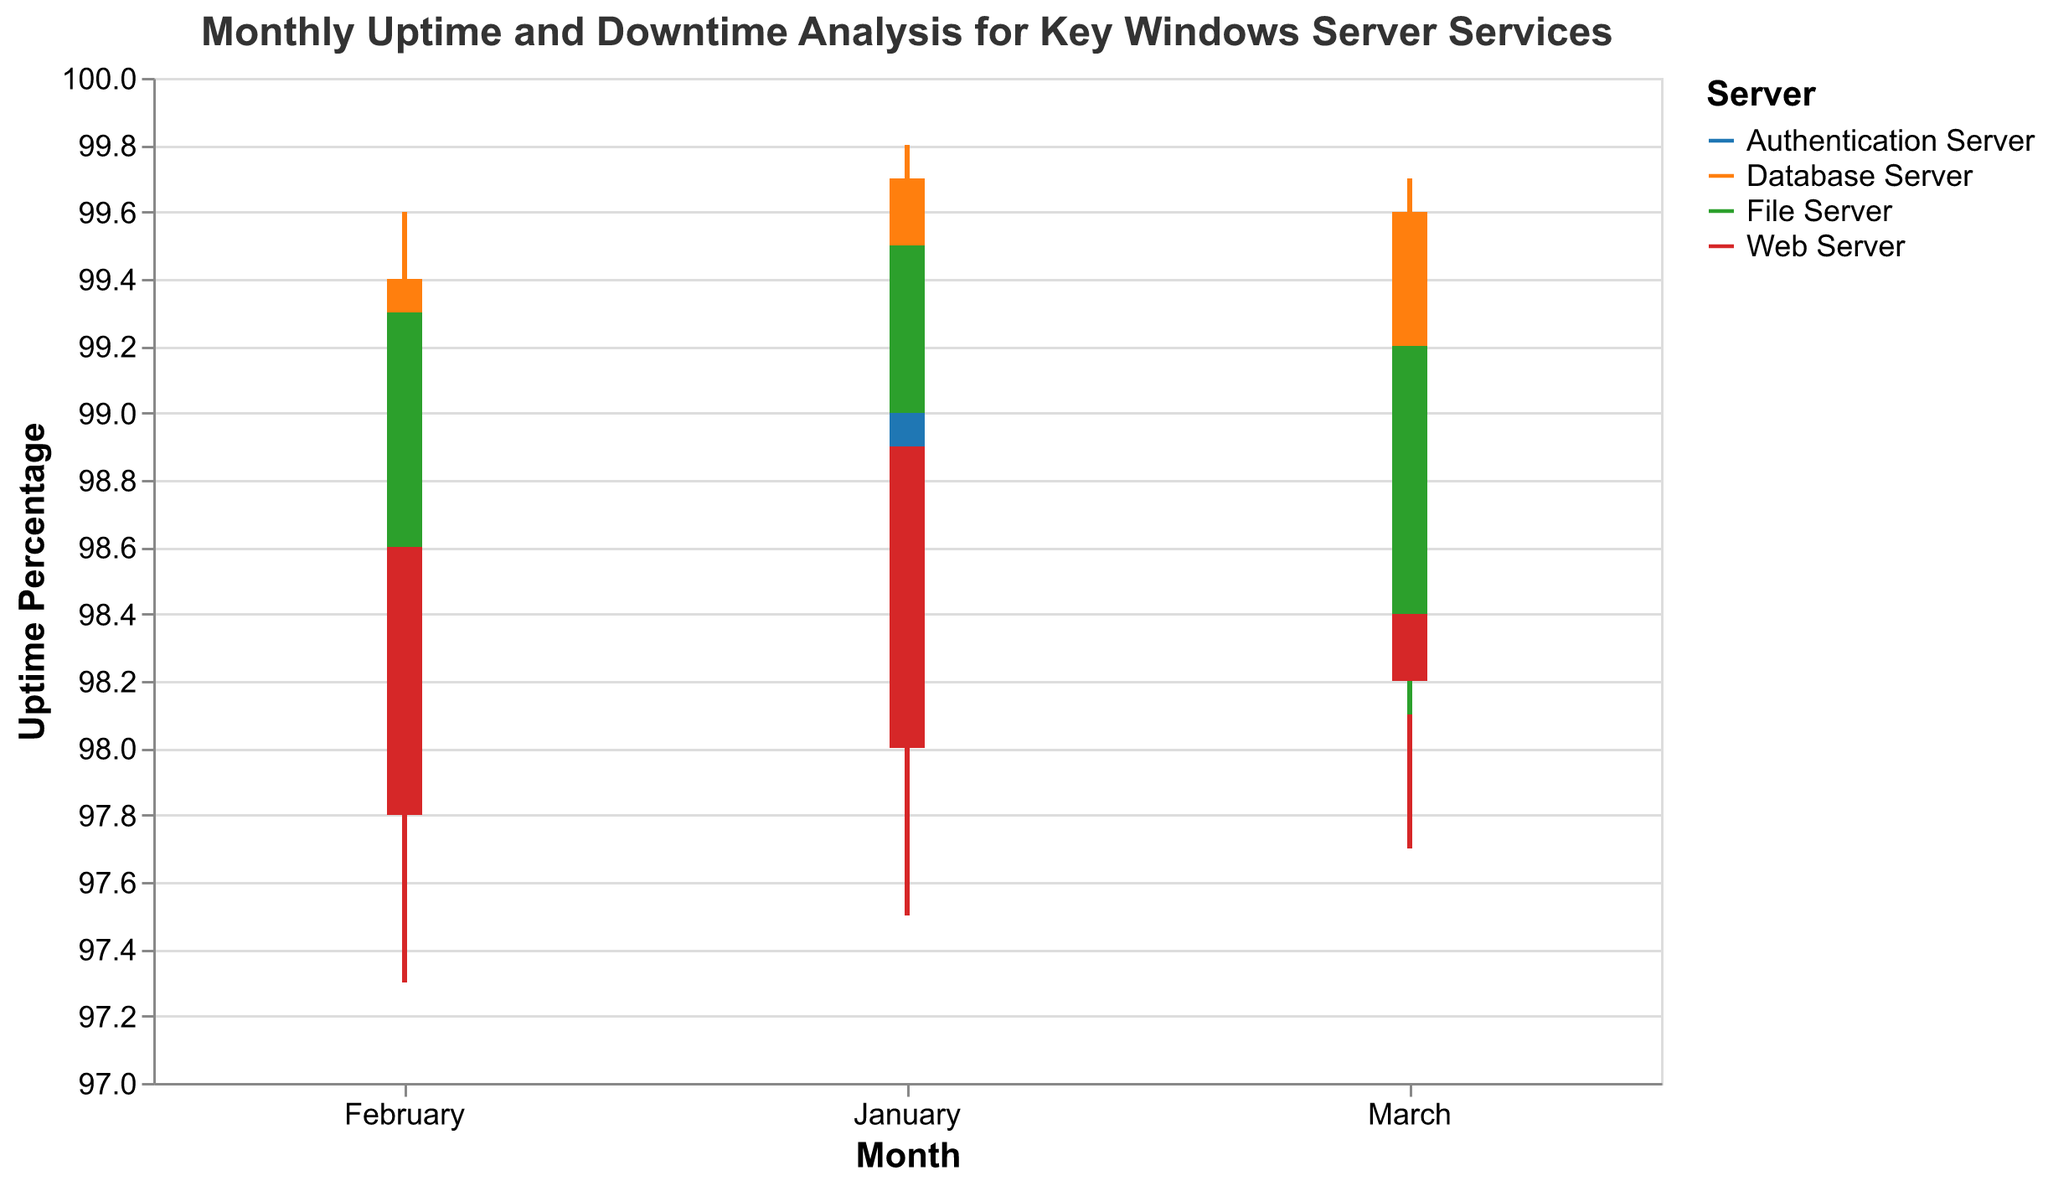What is the title of the figure? The title of the chart is displayed at the top of the figure and clearly states what the plot is representing.
Answer: Monthly Uptime and Downtime Analysis for Key Windows Server Services Which server had the highest uptime in January? By examining the high values in the candlestick plot for January, we can identify the server with the highest uptime.
Answer: Database Server How many servers are represented in the figure? By counting the different colors in the legend of the candlestick chart, we can determine the number of unique servers.
Answer: 4 Which server showed the lowest uptime in March? By looking at the low values in the candlestick plot for March, we can find the server with the lowest recorded uptime.
Answer: Authentication Server What was the uptime range for the Web Server in January? The uptime range can be determined by subtracting the low value from the high value for the Web Server in January.
Answer: 1.6 Compare the closing uptime in March for the Authentication Server and the Database Server. Which is higher? The closing uptime for each server in March can be compared directly from the chart. The Database Server's closing uptime (99.6) is higher than the Authentication Server's closing uptime (99.3).
Answer: Database Server What was the average closing uptime for the Authentication Server over the three months? Add up the closing uptimes for January, February, and March for the Authentication Server and divide by 3. (99.2 + 99.0 + 99.3) / 3 = 99.17
Answer: 99.17 Which server had the most consistent uptime in the first quarter of the year? Consistency can be judged by looking at the variance in the high and low values for each server across the three months. The Database Server shows the least variance.
Answer: Database Server Did any server have a higher closing uptime in February compared to January? If so, which one? By comparing the closing uptime in February to January for each server, we can identify if any server had an increase. The Database Server and File Server had higher closing uptimes in February compared to January.
Answer: Database Server, File Server Which server had the largest drop in uptime between January and February? To find the largest drop, compare the low values between January and February for each server and determine the server with the greatest decrease. The Web Server had the largest drop from 97.5 to 97.3.
Answer: Web Server 